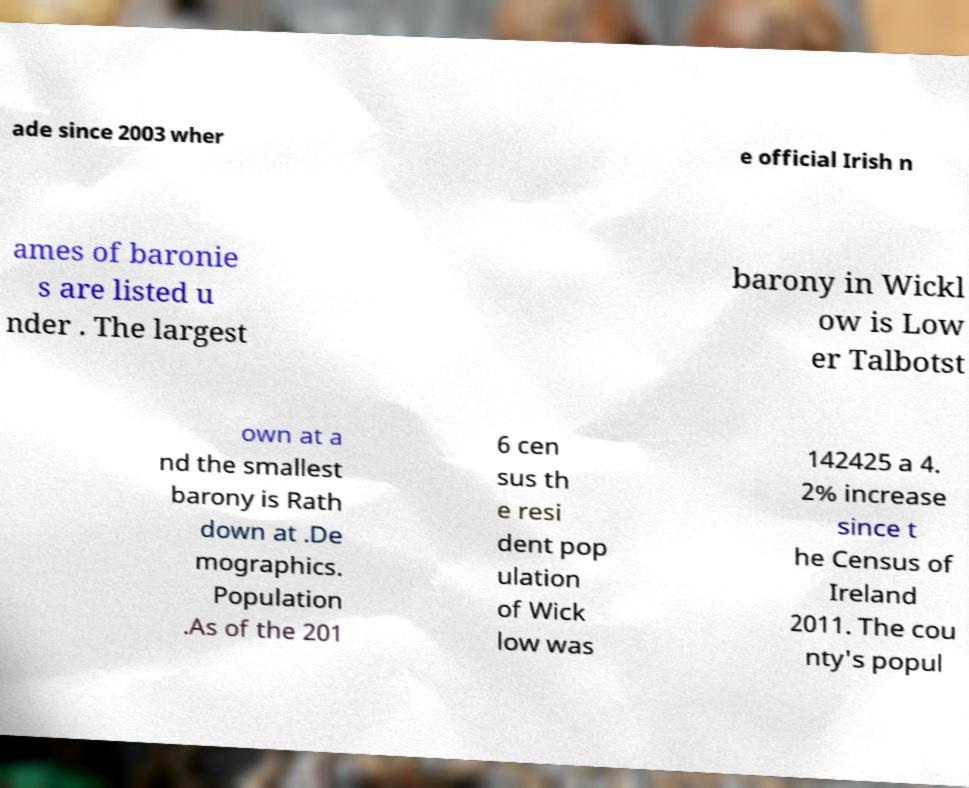Can you accurately transcribe the text from the provided image for me? ade since 2003 wher e official Irish n ames of baronie s are listed u nder . The largest barony in Wickl ow is Low er Talbotst own at a nd the smallest barony is Rath down at .De mographics. Population .As of the 201 6 cen sus th e resi dent pop ulation of Wick low was 142425 a 4. 2% increase since t he Census of Ireland 2011. The cou nty's popul 